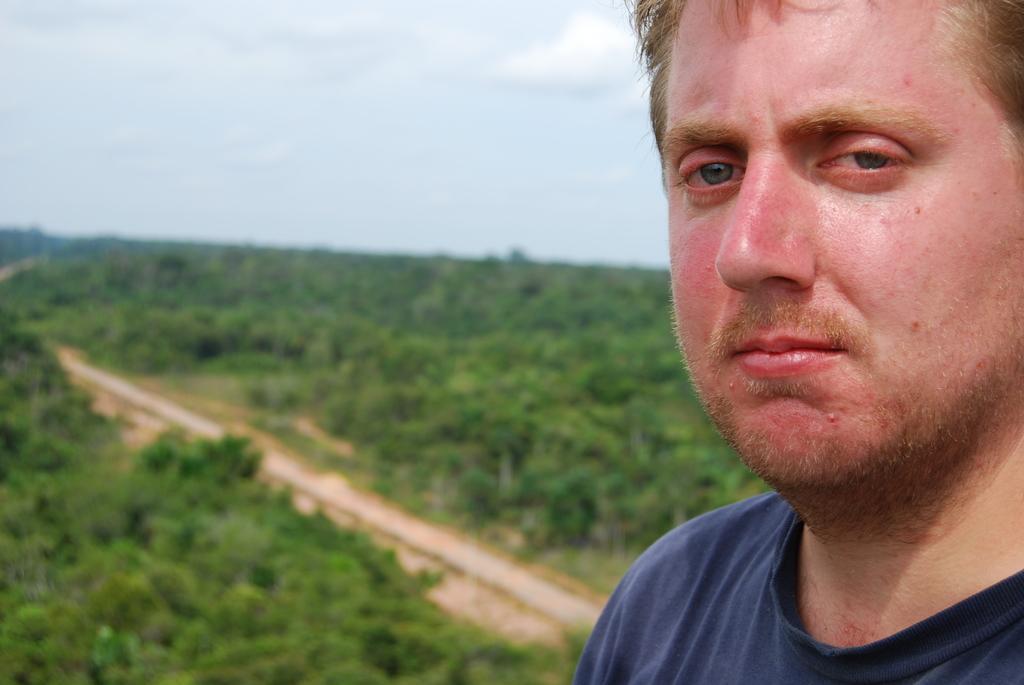Describe this image in one or two sentences. In this image we can see a man wearing the t shirt. In the background we can see the trees and also the path. We can also see the sky. 